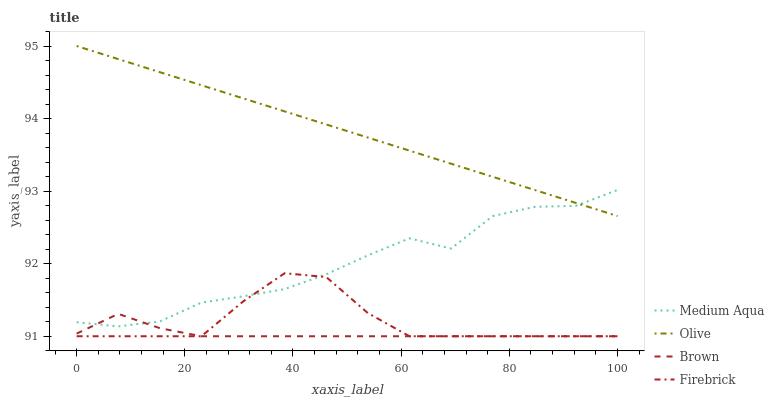Does Brown have the minimum area under the curve?
Answer yes or no. Yes. Does Olive have the maximum area under the curve?
Answer yes or no. Yes. Does Firebrick have the minimum area under the curve?
Answer yes or no. No. Does Firebrick have the maximum area under the curve?
Answer yes or no. No. Is Olive the smoothest?
Answer yes or no. Yes. Is Medium Aqua the roughest?
Answer yes or no. Yes. Is Brown the smoothest?
Answer yes or no. No. Is Brown the roughest?
Answer yes or no. No. Does Brown have the lowest value?
Answer yes or no. Yes. Does Medium Aqua have the lowest value?
Answer yes or no. No. Does Olive have the highest value?
Answer yes or no. Yes. Does Firebrick have the highest value?
Answer yes or no. No. Is Brown less than Olive?
Answer yes or no. Yes. Is Olive greater than Firebrick?
Answer yes or no. Yes. Does Brown intersect Firebrick?
Answer yes or no. Yes. Is Brown less than Firebrick?
Answer yes or no. No. Is Brown greater than Firebrick?
Answer yes or no. No. Does Brown intersect Olive?
Answer yes or no. No. 